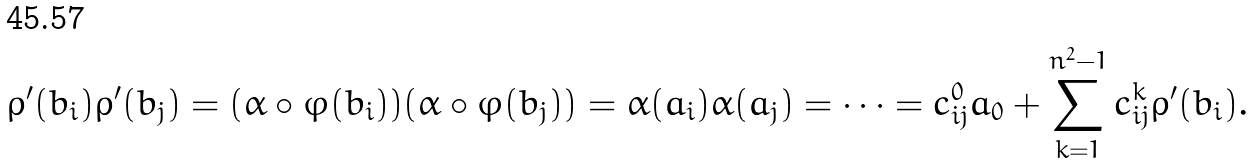Convert formula to latex. <formula><loc_0><loc_0><loc_500><loc_500>\rho ^ { \prime } ( b _ { i } ) \rho ^ { \prime } ( b _ { j } ) = ( \alpha \circ \varphi ( b _ { i } ) ) ( \alpha \circ \varphi ( b _ { j } ) ) = \alpha ( a _ { i } ) \alpha ( a _ { j } ) = \dots = c _ { i j } ^ { 0 } a _ { 0 } + \sum _ { k = 1 } ^ { n ^ { 2 } - 1 } c _ { i j } ^ { k } \rho ^ { \prime } ( b _ { i } ) .</formula> 